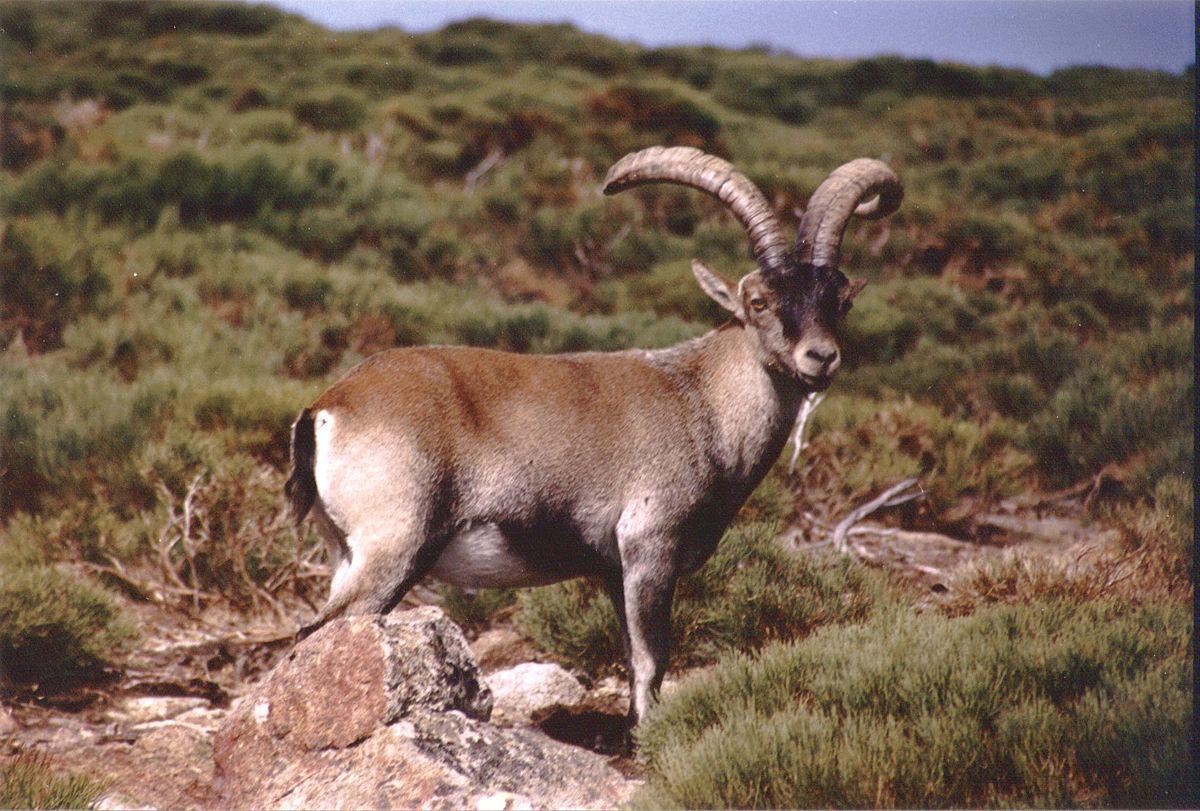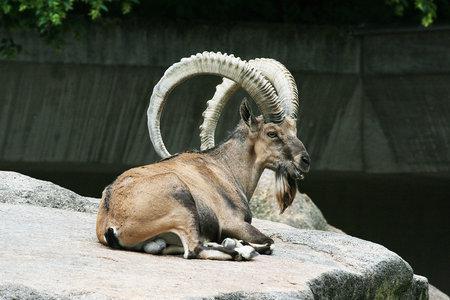The first image is the image on the left, the second image is the image on the right. For the images shown, is this caption "Each picture has the same number of horned mammals in each image, and the right image does not have them standing on four legs." true? Answer yes or no. Yes. The first image is the image on the left, the second image is the image on the right. Given the left and right images, does the statement "Left image shows one horned animal standing with its body turned rightward." hold true? Answer yes or no. Yes. 